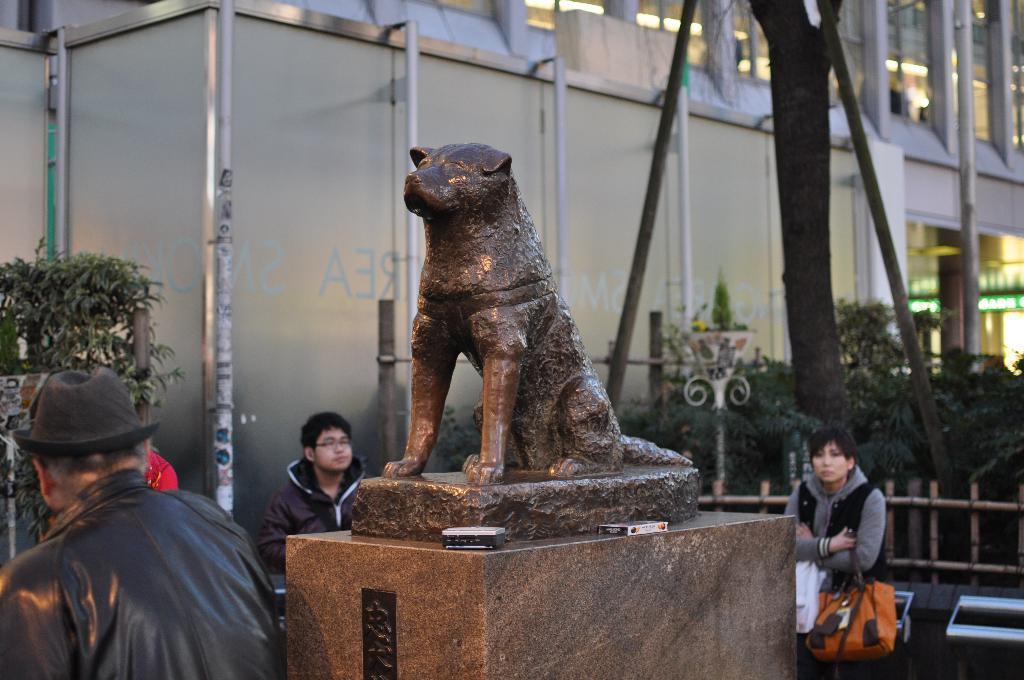Describe this image in one or two sentences. This image is taken outdoors. In the background there is a building. There are a few iron bars. There is a tree. On the left side of the image there is a plant. There are two persons. In the middle of the image there is a statue of an animal and there is a man and a woman. On the right side of the image there are a few plants. There is a railing. There is a board with a text on it. There is an empty bench. 